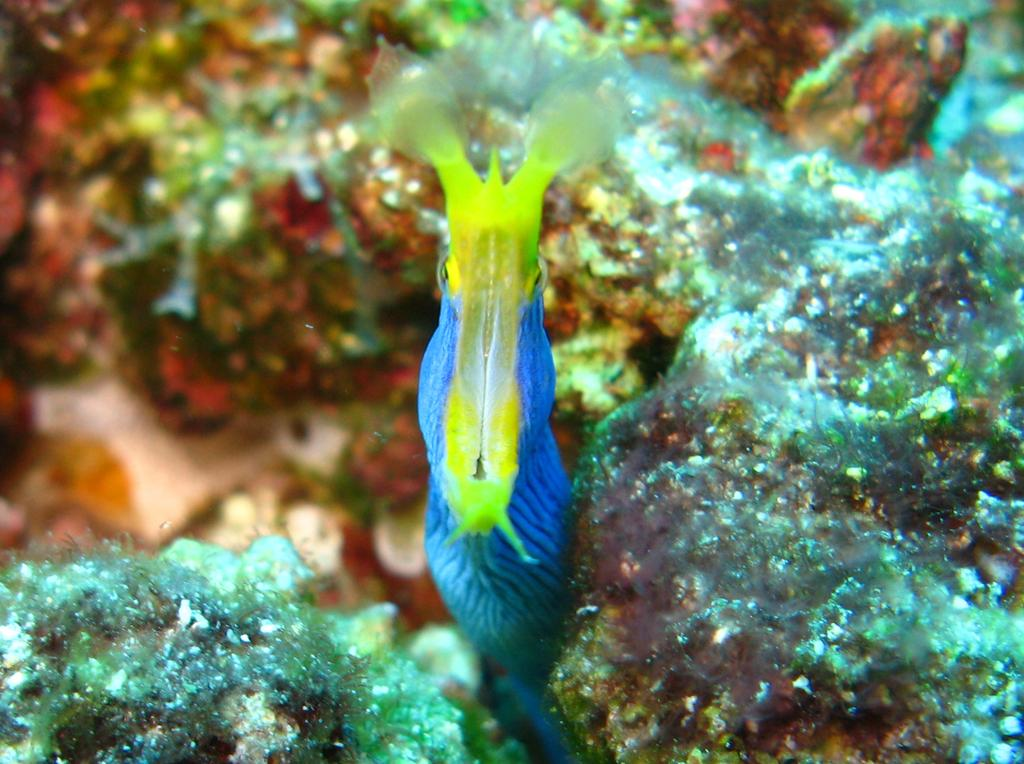What type of natural formation can be seen in the image? There are corals in the image. Can you describe the appearance of the corals? The corals have a unique and colorful appearance in the image. What might be the habitat of these corals? The corals might be found in an underwater environment, such as a coral reef. What is the value of the robin that is flying over the corals in the image? There is no robin present in the image, so it is not possible to determine its value. 